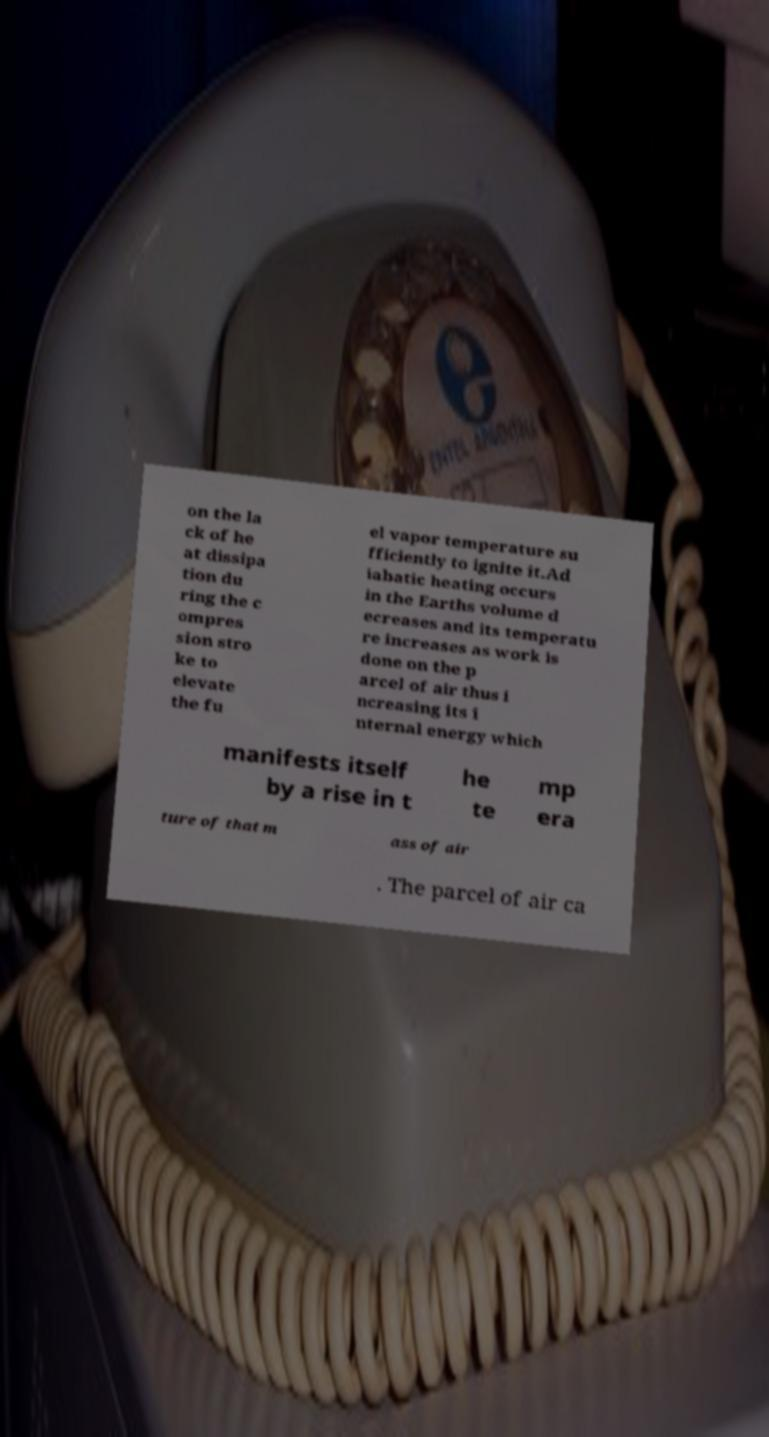Can you accurately transcribe the text from the provided image for me? on the la ck of he at dissipa tion du ring the c ompres sion stro ke to elevate the fu el vapor temperature su fficiently to ignite it.Ad iabatic heating occurs in the Earths volume d ecreases and its temperatu re increases as work is done on the p arcel of air thus i ncreasing its i nternal energy which manifests itself by a rise in t he te mp era ture of that m ass of air . The parcel of air ca 